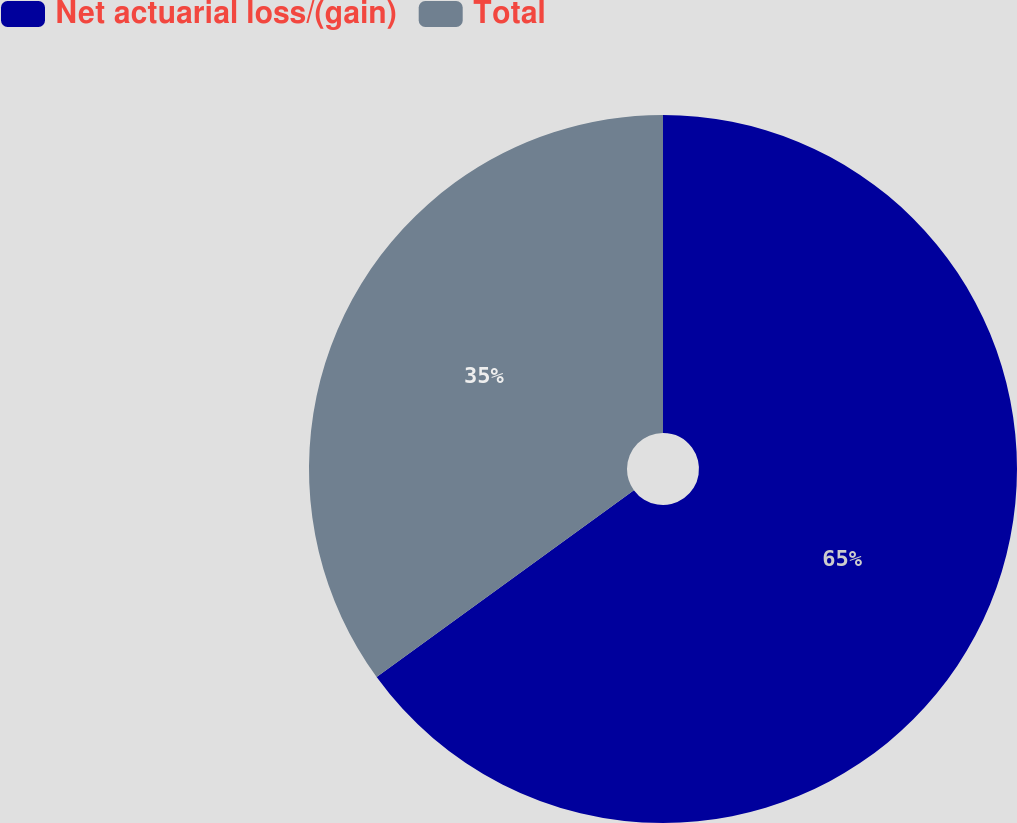Convert chart. <chart><loc_0><loc_0><loc_500><loc_500><pie_chart><fcel>Net actuarial loss/(gain)<fcel>Total<nl><fcel>65.0%<fcel>35.0%<nl></chart> 